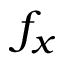<formula> <loc_0><loc_0><loc_500><loc_500>f _ { x }</formula> 